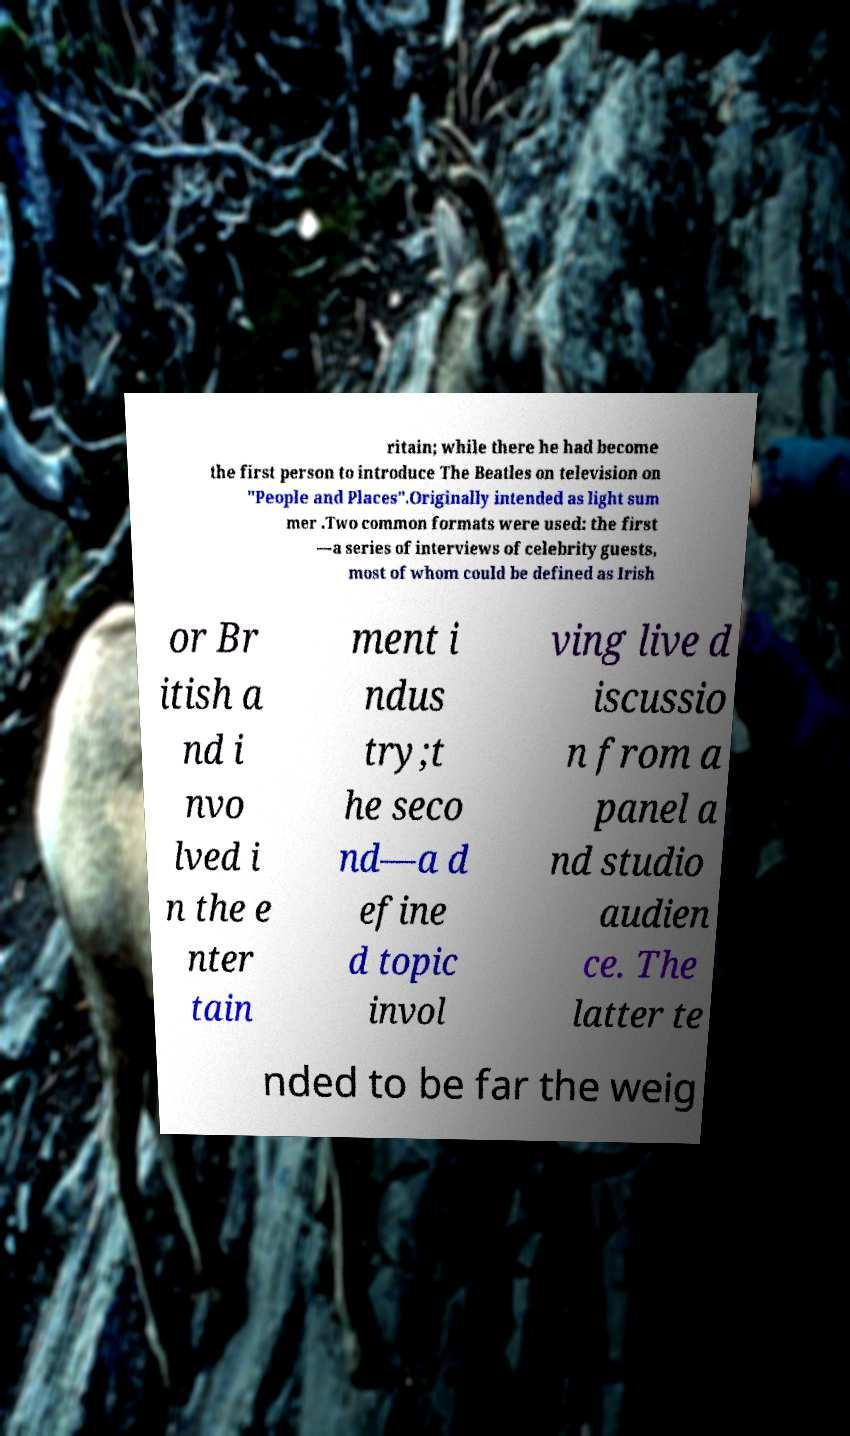Please read and relay the text visible in this image. What does it say? ritain; while there he had become the first person to introduce The Beatles on television on "People and Places".Originally intended as light sum mer .Two common formats were used: the first —a series of interviews of celebrity guests, most of whom could be defined as Irish or Br itish a nd i nvo lved i n the e nter tain ment i ndus try;t he seco nd—a d efine d topic invol ving live d iscussio n from a panel a nd studio audien ce. The latter te nded to be far the weig 